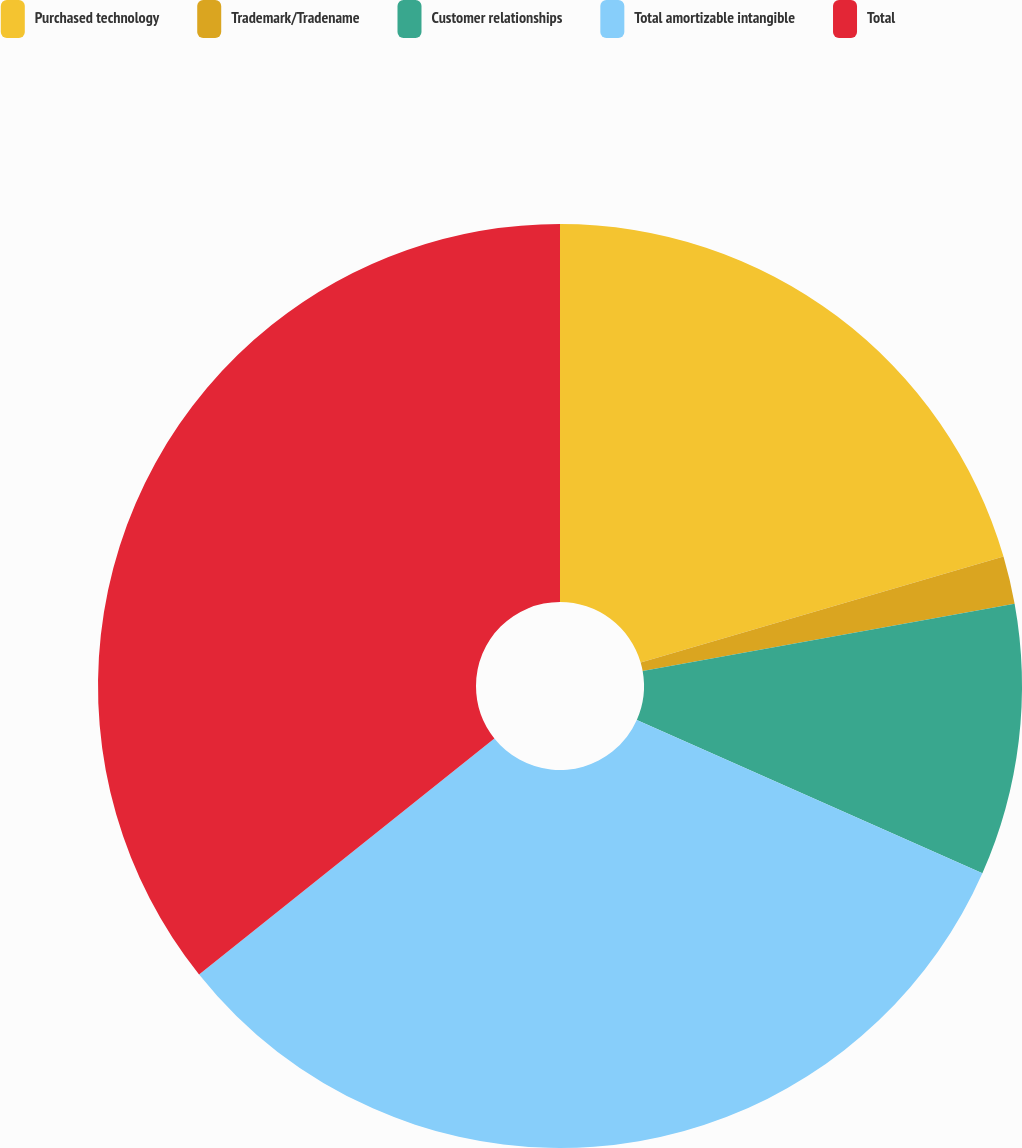Convert chart to OTSL. <chart><loc_0><loc_0><loc_500><loc_500><pie_chart><fcel>Purchased technology<fcel>Trademark/Tradename<fcel>Customer relationships<fcel>Total amortizable intangible<fcel>Total<nl><fcel>20.48%<fcel>1.67%<fcel>9.49%<fcel>32.63%<fcel>35.73%<nl></chart> 